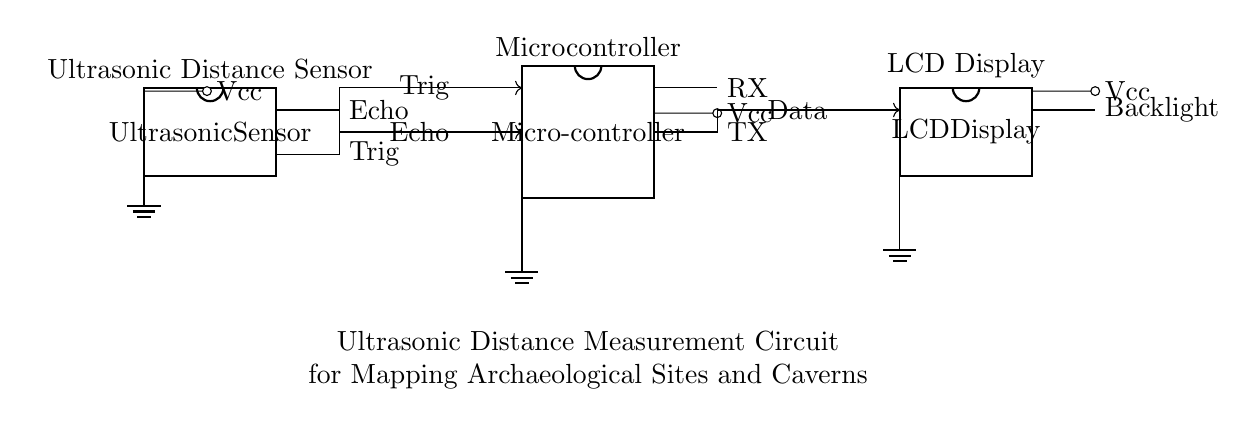What is the main component used for measuring distance? The main component used for measuring distance in this circuit is the ultrasonic sensor, indicated at the left side of the diagram. It emits ultrasonic waves and measures the time it takes for the echoes to return, allowing for distance calculation.
Answer: Ultrasonic sensor How many pins does the microcontroller have? The microcontroller in the circuit has six pins, as shown in the circuit diagram. Each pin serves a specific purpose, such as receiving input from the ultrasonic sensor or outputting data to the display.
Answer: Six What does the 'Trig' pin on the microcontroller do? The 'Trig' pin on the microcontroller is used to initiate the ultrasonic pulse from the ultrasonic sensor. When activated, it sends a signal that prompts the sensor to start measuring the distance by emitting ultrasonic waves.
Answer: Initiate measurement Which component provides power to the circuit? The power supply, represented by 'Vcc' in the circuit, provides electrical power to all components, namely the ultrasonic sensor, microcontroller, and LCD display. Each component connects to this voltage source to function correctly.
Answer: Vcc What type of display is used in the circuit? The circuit uses an LCD display, which is employed to show the distance measurements calculated by the microcontroller based on the ultrasonic sensor readings. The LCD is connected to the microcontroller for data output.
Answer: LCD display How does the microcontroller process the signals from the ultrasonic sensor? The microcontroller processes the signals by interpreting the 'Echo' pin input (which receives the returned ultrasound signal) in conjunction with the 'Trig' pin to determine the time taken for the wave to return. This duration is used to calculate the distance based on the speed of sound in air.
Answer: Processes Echo signal 